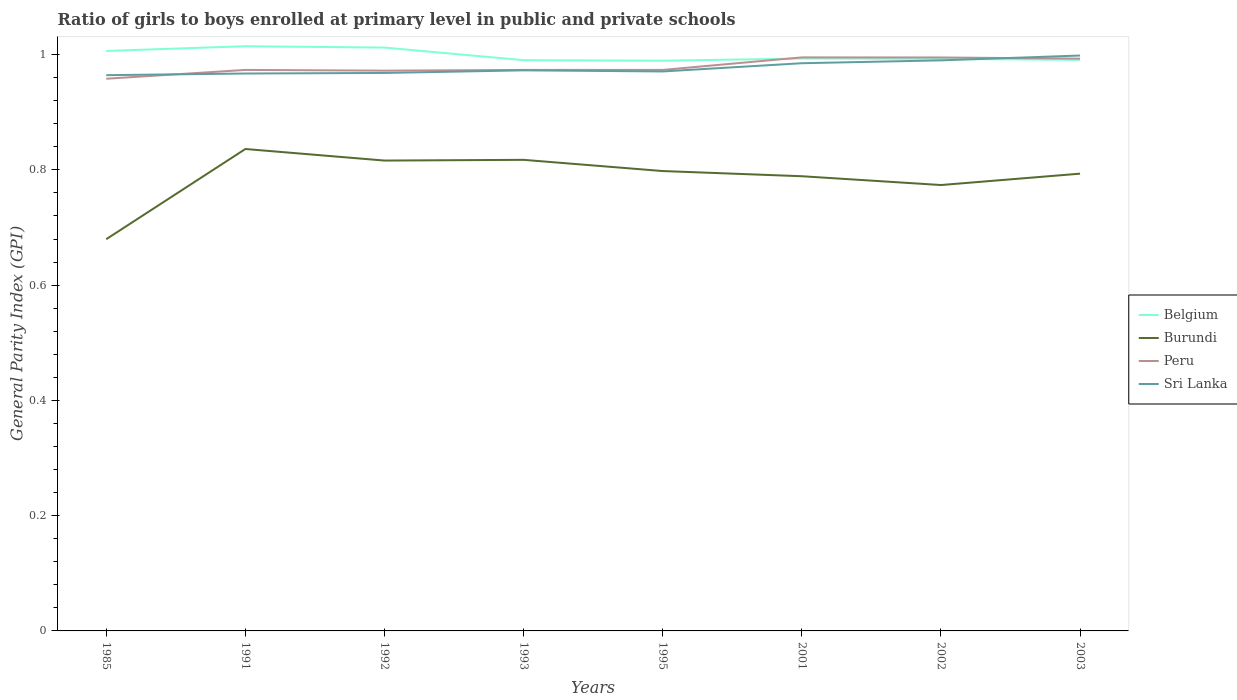Is the number of lines equal to the number of legend labels?
Ensure brevity in your answer.  Yes. Across all years, what is the maximum general parity index in Burundi?
Your answer should be compact. 0.68. What is the total general parity index in Burundi in the graph?
Provide a short and direct response. 0.02. What is the difference between the highest and the second highest general parity index in Peru?
Make the answer very short. 0.04. What is the difference between the highest and the lowest general parity index in Belgium?
Offer a terse response. 3. How many years are there in the graph?
Your answer should be compact. 8. What is the difference between two consecutive major ticks on the Y-axis?
Ensure brevity in your answer.  0.2. Are the values on the major ticks of Y-axis written in scientific E-notation?
Your answer should be compact. No. Does the graph contain any zero values?
Give a very brief answer. No. Does the graph contain grids?
Your response must be concise. No. Where does the legend appear in the graph?
Ensure brevity in your answer.  Center right. How are the legend labels stacked?
Your response must be concise. Vertical. What is the title of the graph?
Offer a terse response. Ratio of girls to boys enrolled at primary level in public and private schools. What is the label or title of the X-axis?
Offer a terse response. Years. What is the label or title of the Y-axis?
Provide a short and direct response. General Parity Index (GPI). What is the General Parity Index (GPI) of Belgium in 1985?
Provide a short and direct response. 1.01. What is the General Parity Index (GPI) in Burundi in 1985?
Your response must be concise. 0.68. What is the General Parity Index (GPI) of Peru in 1985?
Your answer should be compact. 0.96. What is the General Parity Index (GPI) of Sri Lanka in 1985?
Offer a terse response. 0.96. What is the General Parity Index (GPI) of Belgium in 1991?
Keep it short and to the point. 1.01. What is the General Parity Index (GPI) in Burundi in 1991?
Offer a very short reply. 0.84. What is the General Parity Index (GPI) in Peru in 1991?
Ensure brevity in your answer.  0.97. What is the General Parity Index (GPI) of Sri Lanka in 1991?
Provide a succinct answer. 0.97. What is the General Parity Index (GPI) of Belgium in 1992?
Make the answer very short. 1.01. What is the General Parity Index (GPI) of Burundi in 1992?
Your response must be concise. 0.82. What is the General Parity Index (GPI) in Peru in 1992?
Offer a terse response. 0.97. What is the General Parity Index (GPI) in Sri Lanka in 1992?
Offer a terse response. 0.97. What is the General Parity Index (GPI) in Belgium in 1993?
Keep it short and to the point. 0.99. What is the General Parity Index (GPI) in Burundi in 1993?
Provide a succinct answer. 0.82. What is the General Parity Index (GPI) of Peru in 1993?
Provide a short and direct response. 0.97. What is the General Parity Index (GPI) in Sri Lanka in 1993?
Make the answer very short. 0.97. What is the General Parity Index (GPI) of Belgium in 1995?
Offer a terse response. 0.99. What is the General Parity Index (GPI) in Burundi in 1995?
Ensure brevity in your answer.  0.8. What is the General Parity Index (GPI) of Peru in 1995?
Provide a succinct answer. 0.97. What is the General Parity Index (GPI) of Sri Lanka in 1995?
Provide a succinct answer. 0.97. What is the General Parity Index (GPI) in Belgium in 2001?
Offer a terse response. 0.99. What is the General Parity Index (GPI) in Burundi in 2001?
Ensure brevity in your answer.  0.79. What is the General Parity Index (GPI) of Peru in 2001?
Your answer should be compact. 1. What is the General Parity Index (GPI) of Sri Lanka in 2001?
Offer a terse response. 0.99. What is the General Parity Index (GPI) in Belgium in 2002?
Your answer should be very brief. 0.99. What is the General Parity Index (GPI) of Burundi in 2002?
Ensure brevity in your answer.  0.77. What is the General Parity Index (GPI) in Peru in 2002?
Make the answer very short. 1. What is the General Parity Index (GPI) in Sri Lanka in 2002?
Your answer should be very brief. 0.99. What is the General Parity Index (GPI) in Belgium in 2003?
Your answer should be very brief. 0.99. What is the General Parity Index (GPI) in Burundi in 2003?
Offer a very short reply. 0.79. What is the General Parity Index (GPI) of Peru in 2003?
Provide a short and direct response. 0.99. What is the General Parity Index (GPI) in Sri Lanka in 2003?
Ensure brevity in your answer.  1. Across all years, what is the maximum General Parity Index (GPI) in Belgium?
Provide a succinct answer. 1.01. Across all years, what is the maximum General Parity Index (GPI) in Burundi?
Provide a short and direct response. 0.84. Across all years, what is the maximum General Parity Index (GPI) of Peru?
Ensure brevity in your answer.  1. Across all years, what is the maximum General Parity Index (GPI) of Sri Lanka?
Make the answer very short. 1. Across all years, what is the minimum General Parity Index (GPI) in Belgium?
Offer a very short reply. 0.99. Across all years, what is the minimum General Parity Index (GPI) of Burundi?
Your answer should be compact. 0.68. Across all years, what is the minimum General Parity Index (GPI) in Peru?
Keep it short and to the point. 0.96. Across all years, what is the minimum General Parity Index (GPI) in Sri Lanka?
Keep it short and to the point. 0.96. What is the total General Parity Index (GPI) in Belgium in the graph?
Offer a very short reply. 7.99. What is the total General Parity Index (GPI) in Burundi in the graph?
Make the answer very short. 6.3. What is the total General Parity Index (GPI) of Peru in the graph?
Your answer should be compact. 7.83. What is the total General Parity Index (GPI) of Sri Lanka in the graph?
Provide a short and direct response. 7.82. What is the difference between the General Parity Index (GPI) in Belgium in 1985 and that in 1991?
Your answer should be very brief. -0.01. What is the difference between the General Parity Index (GPI) in Burundi in 1985 and that in 1991?
Provide a short and direct response. -0.16. What is the difference between the General Parity Index (GPI) of Peru in 1985 and that in 1991?
Ensure brevity in your answer.  -0.02. What is the difference between the General Parity Index (GPI) in Sri Lanka in 1985 and that in 1991?
Your answer should be compact. -0. What is the difference between the General Parity Index (GPI) of Belgium in 1985 and that in 1992?
Offer a terse response. -0.01. What is the difference between the General Parity Index (GPI) of Burundi in 1985 and that in 1992?
Your answer should be compact. -0.14. What is the difference between the General Parity Index (GPI) in Peru in 1985 and that in 1992?
Your response must be concise. -0.01. What is the difference between the General Parity Index (GPI) of Sri Lanka in 1985 and that in 1992?
Offer a terse response. -0. What is the difference between the General Parity Index (GPI) in Belgium in 1985 and that in 1993?
Keep it short and to the point. 0.02. What is the difference between the General Parity Index (GPI) in Burundi in 1985 and that in 1993?
Keep it short and to the point. -0.14. What is the difference between the General Parity Index (GPI) of Peru in 1985 and that in 1993?
Your answer should be very brief. -0.02. What is the difference between the General Parity Index (GPI) in Sri Lanka in 1985 and that in 1993?
Your answer should be very brief. -0.01. What is the difference between the General Parity Index (GPI) in Belgium in 1985 and that in 1995?
Keep it short and to the point. 0.02. What is the difference between the General Parity Index (GPI) of Burundi in 1985 and that in 1995?
Ensure brevity in your answer.  -0.12. What is the difference between the General Parity Index (GPI) in Peru in 1985 and that in 1995?
Keep it short and to the point. -0.02. What is the difference between the General Parity Index (GPI) of Sri Lanka in 1985 and that in 1995?
Provide a succinct answer. -0.01. What is the difference between the General Parity Index (GPI) in Belgium in 1985 and that in 2001?
Keep it short and to the point. 0.01. What is the difference between the General Parity Index (GPI) of Burundi in 1985 and that in 2001?
Provide a succinct answer. -0.11. What is the difference between the General Parity Index (GPI) of Peru in 1985 and that in 2001?
Make the answer very short. -0.04. What is the difference between the General Parity Index (GPI) in Sri Lanka in 1985 and that in 2001?
Give a very brief answer. -0.02. What is the difference between the General Parity Index (GPI) of Belgium in 1985 and that in 2002?
Offer a very short reply. 0.01. What is the difference between the General Parity Index (GPI) of Burundi in 1985 and that in 2002?
Offer a very short reply. -0.09. What is the difference between the General Parity Index (GPI) of Peru in 1985 and that in 2002?
Ensure brevity in your answer.  -0.04. What is the difference between the General Parity Index (GPI) of Sri Lanka in 1985 and that in 2002?
Provide a succinct answer. -0.03. What is the difference between the General Parity Index (GPI) in Belgium in 1985 and that in 2003?
Offer a terse response. 0.02. What is the difference between the General Parity Index (GPI) in Burundi in 1985 and that in 2003?
Your answer should be compact. -0.11. What is the difference between the General Parity Index (GPI) of Peru in 1985 and that in 2003?
Offer a very short reply. -0.03. What is the difference between the General Parity Index (GPI) in Sri Lanka in 1985 and that in 2003?
Provide a short and direct response. -0.03. What is the difference between the General Parity Index (GPI) in Belgium in 1991 and that in 1992?
Your answer should be compact. 0. What is the difference between the General Parity Index (GPI) in Burundi in 1991 and that in 1992?
Your response must be concise. 0.02. What is the difference between the General Parity Index (GPI) in Peru in 1991 and that in 1992?
Give a very brief answer. 0. What is the difference between the General Parity Index (GPI) of Sri Lanka in 1991 and that in 1992?
Provide a succinct answer. -0. What is the difference between the General Parity Index (GPI) of Belgium in 1991 and that in 1993?
Make the answer very short. 0.02. What is the difference between the General Parity Index (GPI) of Burundi in 1991 and that in 1993?
Keep it short and to the point. 0.02. What is the difference between the General Parity Index (GPI) of Sri Lanka in 1991 and that in 1993?
Give a very brief answer. -0.01. What is the difference between the General Parity Index (GPI) in Belgium in 1991 and that in 1995?
Your answer should be very brief. 0.03. What is the difference between the General Parity Index (GPI) of Burundi in 1991 and that in 1995?
Your answer should be compact. 0.04. What is the difference between the General Parity Index (GPI) in Sri Lanka in 1991 and that in 1995?
Provide a succinct answer. -0. What is the difference between the General Parity Index (GPI) in Belgium in 1991 and that in 2001?
Your response must be concise. 0.02. What is the difference between the General Parity Index (GPI) of Burundi in 1991 and that in 2001?
Ensure brevity in your answer.  0.05. What is the difference between the General Parity Index (GPI) in Peru in 1991 and that in 2001?
Provide a short and direct response. -0.02. What is the difference between the General Parity Index (GPI) of Sri Lanka in 1991 and that in 2001?
Your answer should be very brief. -0.02. What is the difference between the General Parity Index (GPI) in Belgium in 1991 and that in 2002?
Offer a very short reply. 0.02. What is the difference between the General Parity Index (GPI) of Burundi in 1991 and that in 2002?
Your answer should be very brief. 0.06. What is the difference between the General Parity Index (GPI) of Peru in 1991 and that in 2002?
Give a very brief answer. -0.02. What is the difference between the General Parity Index (GPI) of Sri Lanka in 1991 and that in 2002?
Provide a short and direct response. -0.02. What is the difference between the General Parity Index (GPI) in Belgium in 1991 and that in 2003?
Keep it short and to the point. 0.02. What is the difference between the General Parity Index (GPI) in Burundi in 1991 and that in 2003?
Offer a terse response. 0.04. What is the difference between the General Parity Index (GPI) of Peru in 1991 and that in 2003?
Keep it short and to the point. -0.02. What is the difference between the General Parity Index (GPI) of Sri Lanka in 1991 and that in 2003?
Your answer should be compact. -0.03. What is the difference between the General Parity Index (GPI) of Belgium in 1992 and that in 1993?
Make the answer very short. 0.02. What is the difference between the General Parity Index (GPI) of Burundi in 1992 and that in 1993?
Your response must be concise. -0. What is the difference between the General Parity Index (GPI) of Peru in 1992 and that in 1993?
Your response must be concise. -0. What is the difference between the General Parity Index (GPI) in Sri Lanka in 1992 and that in 1993?
Provide a succinct answer. -0. What is the difference between the General Parity Index (GPI) in Belgium in 1992 and that in 1995?
Make the answer very short. 0.02. What is the difference between the General Parity Index (GPI) of Burundi in 1992 and that in 1995?
Your answer should be very brief. 0.02. What is the difference between the General Parity Index (GPI) of Peru in 1992 and that in 1995?
Your response must be concise. -0. What is the difference between the General Parity Index (GPI) in Sri Lanka in 1992 and that in 1995?
Ensure brevity in your answer.  -0. What is the difference between the General Parity Index (GPI) of Belgium in 1992 and that in 2001?
Offer a terse response. 0.02. What is the difference between the General Parity Index (GPI) of Burundi in 1992 and that in 2001?
Offer a terse response. 0.03. What is the difference between the General Parity Index (GPI) of Peru in 1992 and that in 2001?
Make the answer very short. -0.02. What is the difference between the General Parity Index (GPI) in Sri Lanka in 1992 and that in 2001?
Offer a very short reply. -0.02. What is the difference between the General Parity Index (GPI) in Belgium in 1992 and that in 2002?
Your answer should be compact. 0.02. What is the difference between the General Parity Index (GPI) of Burundi in 1992 and that in 2002?
Give a very brief answer. 0.04. What is the difference between the General Parity Index (GPI) of Peru in 1992 and that in 2002?
Your answer should be very brief. -0.02. What is the difference between the General Parity Index (GPI) in Sri Lanka in 1992 and that in 2002?
Ensure brevity in your answer.  -0.02. What is the difference between the General Parity Index (GPI) of Belgium in 1992 and that in 2003?
Your answer should be compact. 0.02. What is the difference between the General Parity Index (GPI) in Burundi in 1992 and that in 2003?
Keep it short and to the point. 0.02. What is the difference between the General Parity Index (GPI) of Peru in 1992 and that in 2003?
Give a very brief answer. -0.02. What is the difference between the General Parity Index (GPI) of Sri Lanka in 1992 and that in 2003?
Keep it short and to the point. -0.03. What is the difference between the General Parity Index (GPI) of Belgium in 1993 and that in 1995?
Your answer should be compact. 0. What is the difference between the General Parity Index (GPI) in Burundi in 1993 and that in 1995?
Provide a succinct answer. 0.02. What is the difference between the General Parity Index (GPI) of Peru in 1993 and that in 1995?
Give a very brief answer. -0. What is the difference between the General Parity Index (GPI) in Sri Lanka in 1993 and that in 1995?
Offer a terse response. 0. What is the difference between the General Parity Index (GPI) of Belgium in 1993 and that in 2001?
Your answer should be very brief. -0. What is the difference between the General Parity Index (GPI) of Burundi in 1993 and that in 2001?
Provide a short and direct response. 0.03. What is the difference between the General Parity Index (GPI) in Peru in 1993 and that in 2001?
Your answer should be compact. -0.02. What is the difference between the General Parity Index (GPI) of Sri Lanka in 1993 and that in 2001?
Offer a very short reply. -0.01. What is the difference between the General Parity Index (GPI) of Belgium in 1993 and that in 2002?
Offer a very short reply. -0. What is the difference between the General Parity Index (GPI) in Burundi in 1993 and that in 2002?
Give a very brief answer. 0.04. What is the difference between the General Parity Index (GPI) of Peru in 1993 and that in 2002?
Provide a short and direct response. -0.02. What is the difference between the General Parity Index (GPI) of Sri Lanka in 1993 and that in 2002?
Offer a very short reply. -0.02. What is the difference between the General Parity Index (GPI) of Belgium in 1993 and that in 2003?
Your answer should be very brief. -0. What is the difference between the General Parity Index (GPI) of Burundi in 1993 and that in 2003?
Keep it short and to the point. 0.02. What is the difference between the General Parity Index (GPI) in Peru in 1993 and that in 2003?
Provide a short and direct response. -0.02. What is the difference between the General Parity Index (GPI) of Sri Lanka in 1993 and that in 2003?
Offer a terse response. -0.03. What is the difference between the General Parity Index (GPI) in Belgium in 1995 and that in 2001?
Provide a succinct answer. -0. What is the difference between the General Parity Index (GPI) in Burundi in 1995 and that in 2001?
Your response must be concise. 0.01. What is the difference between the General Parity Index (GPI) in Peru in 1995 and that in 2001?
Your response must be concise. -0.02. What is the difference between the General Parity Index (GPI) in Sri Lanka in 1995 and that in 2001?
Ensure brevity in your answer.  -0.01. What is the difference between the General Parity Index (GPI) in Belgium in 1995 and that in 2002?
Provide a succinct answer. -0. What is the difference between the General Parity Index (GPI) in Burundi in 1995 and that in 2002?
Give a very brief answer. 0.02. What is the difference between the General Parity Index (GPI) of Peru in 1995 and that in 2002?
Provide a succinct answer. -0.02. What is the difference between the General Parity Index (GPI) in Sri Lanka in 1995 and that in 2002?
Provide a short and direct response. -0.02. What is the difference between the General Parity Index (GPI) in Belgium in 1995 and that in 2003?
Your answer should be compact. -0. What is the difference between the General Parity Index (GPI) in Burundi in 1995 and that in 2003?
Offer a very short reply. 0. What is the difference between the General Parity Index (GPI) of Peru in 1995 and that in 2003?
Your answer should be compact. -0.02. What is the difference between the General Parity Index (GPI) in Sri Lanka in 1995 and that in 2003?
Provide a short and direct response. -0.03. What is the difference between the General Parity Index (GPI) of Belgium in 2001 and that in 2002?
Provide a short and direct response. 0. What is the difference between the General Parity Index (GPI) of Burundi in 2001 and that in 2002?
Offer a very short reply. 0.02. What is the difference between the General Parity Index (GPI) in Sri Lanka in 2001 and that in 2002?
Provide a short and direct response. -0.01. What is the difference between the General Parity Index (GPI) in Belgium in 2001 and that in 2003?
Your answer should be compact. 0. What is the difference between the General Parity Index (GPI) in Burundi in 2001 and that in 2003?
Provide a short and direct response. -0. What is the difference between the General Parity Index (GPI) of Peru in 2001 and that in 2003?
Offer a terse response. 0. What is the difference between the General Parity Index (GPI) in Sri Lanka in 2001 and that in 2003?
Make the answer very short. -0.01. What is the difference between the General Parity Index (GPI) in Belgium in 2002 and that in 2003?
Provide a short and direct response. 0. What is the difference between the General Parity Index (GPI) of Burundi in 2002 and that in 2003?
Offer a terse response. -0.02. What is the difference between the General Parity Index (GPI) of Peru in 2002 and that in 2003?
Your answer should be very brief. 0. What is the difference between the General Parity Index (GPI) of Sri Lanka in 2002 and that in 2003?
Provide a succinct answer. -0.01. What is the difference between the General Parity Index (GPI) in Belgium in 1985 and the General Parity Index (GPI) in Burundi in 1991?
Make the answer very short. 0.17. What is the difference between the General Parity Index (GPI) in Belgium in 1985 and the General Parity Index (GPI) in Peru in 1991?
Your answer should be compact. 0.03. What is the difference between the General Parity Index (GPI) in Belgium in 1985 and the General Parity Index (GPI) in Sri Lanka in 1991?
Your answer should be very brief. 0.04. What is the difference between the General Parity Index (GPI) in Burundi in 1985 and the General Parity Index (GPI) in Peru in 1991?
Make the answer very short. -0.29. What is the difference between the General Parity Index (GPI) in Burundi in 1985 and the General Parity Index (GPI) in Sri Lanka in 1991?
Ensure brevity in your answer.  -0.29. What is the difference between the General Parity Index (GPI) of Peru in 1985 and the General Parity Index (GPI) of Sri Lanka in 1991?
Your response must be concise. -0.01. What is the difference between the General Parity Index (GPI) of Belgium in 1985 and the General Parity Index (GPI) of Burundi in 1992?
Provide a short and direct response. 0.19. What is the difference between the General Parity Index (GPI) in Belgium in 1985 and the General Parity Index (GPI) in Peru in 1992?
Ensure brevity in your answer.  0.03. What is the difference between the General Parity Index (GPI) in Belgium in 1985 and the General Parity Index (GPI) in Sri Lanka in 1992?
Provide a succinct answer. 0.04. What is the difference between the General Parity Index (GPI) of Burundi in 1985 and the General Parity Index (GPI) of Peru in 1992?
Your response must be concise. -0.29. What is the difference between the General Parity Index (GPI) in Burundi in 1985 and the General Parity Index (GPI) in Sri Lanka in 1992?
Provide a succinct answer. -0.29. What is the difference between the General Parity Index (GPI) in Peru in 1985 and the General Parity Index (GPI) in Sri Lanka in 1992?
Give a very brief answer. -0.01. What is the difference between the General Parity Index (GPI) in Belgium in 1985 and the General Parity Index (GPI) in Burundi in 1993?
Offer a very short reply. 0.19. What is the difference between the General Parity Index (GPI) of Belgium in 1985 and the General Parity Index (GPI) of Peru in 1993?
Provide a succinct answer. 0.03. What is the difference between the General Parity Index (GPI) of Belgium in 1985 and the General Parity Index (GPI) of Sri Lanka in 1993?
Your answer should be very brief. 0.03. What is the difference between the General Parity Index (GPI) in Burundi in 1985 and the General Parity Index (GPI) in Peru in 1993?
Your answer should be compact. -0.29. What is the difference between the General Parity Index (GPI) in Burundi in 1985 and the General Parity Index (GPI) in Sri Lanka in 1993?
Ensure brevity in your answer.  -0.29. What is the difference between the General Parity Index (GPI) of Peru in 1985 and the General Parity Index (GPI) of Sri Lanka in 1993?
Offer a very short reply. -0.01. What is the difference between the General Parity Index (GPI) in Belgium in 1985 and the General Parity Index (GPI) in Burundi in 1995?
Provide a short and direct response. 0.21. What is the difference between the General Parity Index (GPI) of Belgium in 1985 and the General Parity Index (GPI) of Peru in 1995?
Your answer should be very brief. 0.03. What is the difference between the General Parity Index (GPI) in Belgium in 1985 and the General Parity Index (GPI) in Sri Lanka in 1995?
Give a very brief answer. 0.04. What is the difference between the General Parity Index (GPI) in Burundi in 1985 and the General Parity Index (GPI) in Peru in 1995?
Offer a very short reply. -0.29. What is the difference between the General Parity Index (GPI) in Burundi in 1985 and the General Parity Index (GPI) in Sri Lanka in 1995?
Give a very brief answer. -0.29. What is the difference between the General Parity Index (GPI) in Peru in 1985 and the General Parity Index (GPI) in Sri Lanka in 1995?
Make the answer very short. -0.01. What is the difference between the General Parity Index (GPI) in Belgium in 1985 and the General Parity Index (GPI) in Burundi in 2001?
Make the answer very short. 0.22. What is the difference between the General Parity Index (GPI) of Belgium in 1985 and the General Parity Index (GPI) of Peru in 2001?
Your answer should be compact. 0.01. What is the difference between the General Parity Index (GPI) in Belgium in 1985 and the General Parity Index (GPI) in Sri Lanka in 2001?
Offer a terse response. 0.02. What is the difference between the General Parity Index (GPI) in Burundi in 1985 and the General Parity Index (GPI) in Peru in 2001?
Offer a terse response. -0.32. What is the difference between the General Parity Index (GPI) of Burundi in 1985 and the General Parity Index (GPI) of Sri Lanka in 2001?
Your response must be concise. -0.31. What is the difference between the General Parity Index (GPI) in Peru in 1985 and the General Parity Index (GPI) in Sri Lanka in 2001?
Make the answer very short. -0.03. What is the difference between the General Parity Index (GPI) of Belgium in 1985 and the General Parity Index (GPI) of Burundi in 2002?
Your response must be concise. 0.23. What is the difference between the General Parity Index (GPI) of Belgium in 1985 and the General Parity Index (GPI) of Peru in 2002?
Your answer should be very brief. 0.01. What is the difference between the General Parity Index (GPI) in Belgium in 1985 and the General Parity Index (GPI) in Sri Lanka in 2002?
Make the answer very short. 0.02. What is the difference between the General Parity Index (GPI) in Burundi in 1985 and the General Parity Index (GPI) in Peru in 2002?
Make the answer very short. -0.32. What is the difference between the General Parity Index (GPI) of Burundi in 1985 and the General Parity Index (GPI) of Sri Lanka in 2002?
Make the answer very short. -0.31. What is the difference between the General Parity Index (GPI) in Peru in 1985 and the General Parity Index (GPI) in Sri Lanka in 2002?
Ensure brevity in your answer.  -0.03. What is the difference between the General Parity Index (GPI) in Belgium in 1985 and the General Parity Index (GPI) in Burundi in 2003?
Your answer should be compact. 0.21. What is the difference between the General Parity Index (GPI) in Belgium in 1985 and the General Parity Index (GPI) in Peru in 2003?
Your answer should be compact. 0.01. What is the difference between the General Parity Index (GPI) of Belgium in 1985 and the General Parity Index (GPI) of Sri Lanka in 2003?
Your response must be concise. 0.01. What is the difference between the General Parity Index (GPI) of Burundi in 1985 and the General Parity Index (GPI) of Peru in 2003?
Offer a very short reply. -0.31. What is the difference between the General Parity Index (GPI) in Burundi in 1985 and the General Parity Index (GPI) in Sri Lanka in 2003?
Offer a terse response. -0.32. What is the difference between the General Parity Index (GPI) of Peru in 1985 and the General Parity Index (GPI) of Sri Lanka in 2003?
Your answer should be very brief. -0.04. What is the difference between the General Parity Index (GPI) of Belgium in 1991 and the General Parity Index (GPI) of Burundi in 1992?
Your answer should be compact. 0.2. What is the difference between the General Parity Index (GPI) of Belgium in 1991 and the General Parity Index (GPI) of Peru in 1992?
Provide a short and direct response. 0.04. What is the difference between the General Parity Index (GPI) in Belgium in 1991 and the General Parity Index (GPI) in Sri Lanka in 1992?
Offer a terse response. 0.05. What is the difference between the General Parity Index (GPI) in Burundi in 1991 and the General Parity Index (GPI) in Peru in 1992?
Offer a terse response. -0.14. What is the difference between the General Parity Index (GPI) of Burundi in 1991 and the General Parity Index (GPI) of Sri Lanka in 1992?
Offer a terse response. -0.13. What is the difference between the General Parity Index (GPI) of Peru in 1991 and the General Parity Index (GPI) of Sri Lanka in 1992?
Make the answer very short. 0.01. What is the difference between the General Parity Index (GPI) in Belgium in 1991 and the General Parity Index (GPI) in Burundi in 1993?
Provide a succinct answer. 0.2. What is the difference between the General Parity Index (GPI) of Belgium in 1991 and the General Parity Index (GPI) of Peru in 1993?
Keep it short and to the point. 0.04. What is the difference between the General Parity Index (GPI) in Belgium in 1991 and the General Parity Index (GPI) in Sri Lanka in 1993?
Provide a succinct answer. 0.04. What is the difference between the General Parity Index (GPI) of Burundi in 1991 and the General Parity Index (GPI) of Peru in 1993?
Your response must be concise. -0.14. What is the difference between the General Parity Index (GPI) in Burundi in 1991 and the General Parity Index (GPI) in Sri Lanka in 1993?
Provide a short and direct response. -0.14. What is the difference between the General Parity Index (GPI) of Peru in 1991 and the General Parity Index (GPI) of Sri Lanka in 1993?
Offer a very short reply. 0. What is the difference between the General Parity Index (GPI) of Belgium in 1991 and the General Parity Index (GPI) of Burundi in 1995?
Ensure brevity in your answer.  0.22. What is the difference between the General Parity Index (GPI) in Belgium in 1991 and the General Parity Index (GPI) in Peru in 1995?
Make the answer very short. 0.04. What is the difference between the General Parity Index (GPI) of Belgium in 1991 and the General Parity Index (GPI) of Sri Lanka in 1995?
Provide a succinct answer. 0.04. What is the difference between the General Parity Index (GPI) of Burundi in 1991 and the General Parity Index (GPI) of Peru in 1995?
Your response must be concise. -0.14. What is the difference between the General Parity Index (GPI) of Burundi in 1991 and the General Parity Index (GPI) of Sri Lanka in 1995?
Keep it short and to the point. -0.13. What is the difference between the General Parity Index (GPI) of Peru in 1991 and the General Parity Index (GPI) of Sri Lanka in 1995?
Provide a succinct answer. 0. What is the difference between the General Parity Index (GPI) in Belgium in 1991 and the General Parity Index (GPI) in Burundi in 2001?
Give a very brief answer. 0.23. What is the difference between the General Parity Index (GPI) in Belgium in 1991 and the General Parity Index (GPI) in Peru in 2001?
Keep it short and to the point. 0.02. What is the difference between the General Parity Index (GPI) of Belgium in 1991 and the General Parity Index (GPI) of Sri Lanka in 2001?
Provide a short and direct response. 0.03. What is the difference between the General Parity Index (GPI) of Burundi in 1991 and the General Parity Index (GPI) of Peru in 2001?
Give a very brief answer. -0.16. What is the difference between the General Parity Index (GPI) in Burundi in 1991 and the General Parity Index (GPI) in Sri Lanka in 2001?
Ensure brevity in your answer.  -0.15. What is the difference between the General Parity Index (GPI) of Peru in 1991 and the General Parity Index (GPI) of Sri Lanka in 2001?
Your response must be concise. -0.01. What is the difference between the General Parity Index (GPI) of Belgium in 1991 and the General Parity Index (GPI) of Burundi in 2002?
Your answer should be compact. 0.24. What is the difference between the General Parity Index (GPI) of Belgium in 1991 and the General Parity Index (GPI) of Peru in 2002?
Give a very brief answer. 0.02. What is the difference between the General Parity Index (GPI) of Belgium in 1991 and the General Parity Index (GPI) of Sri Lanka in 2002?
Give a very brief answer. 0.02. What is the difference between the General Parity Index (GPI) of Burundi in 1991 and the General Parity Index (GPI) of Peru in 2002?
Your answer should be compact. -0.16. What is the difference between the General Parity Index (GPI) in Burundi in 1991 and the General Parity Index (GPI) in Sri Lanka in 2002?
Ensure brevity in your answer.  -0.15. What is the difference between the General Parity Index (GPI) in Peru in 1991 and the General Parity Index (GPI) in Sri Lanka in 2002?
Offer a very short reply. -0.02. What is the difference between the General Parity Index (GPI) in Belgium in 1991 and the General Parity Index (GPI) in Burundi in 2003?
Make the answer very short. 0.22. What is the difference between the General Parity Index (GPI) of Belgium in 1991 and the General Parity Index (GPI) of Peru in 2003?
Ensure brevity in your answer.  0.02. What is the difference between the General Parity Index (GPI) in Belgium in 1991 and the General Parity Index (GPI) in Sri Lanka in 2003?
Provide a succinct answer. 0.02. What is the difference between the General Parity Index (GPI) of Burundi in 1991 and the General Parity Index (GPI) of Peru in 2003?
Give a very brief answer. -0.16. What is the difference between the General Parity Index (GPI) of Burundi in 1991 and the General Parity Index (GPI) of Sri Lanka in 2003?
Offer a very short reply. -0.16. What is the difference between the General Parity Index (GPI) in Peru in 1991 and the General Parity Index (GPI) in Sri Lanka in 2003?
Ensure brevity in your answer.  -0.03. What is the difference between the General Parity Index (GPI) in Belgium in 1992 and the General Parity Index (GPI) in Burundi in 1993?
Give a very brief answer. 0.19. What is the difference between the General Parity Index (GPI) in Belgium in 1992 and the General Parity Index (GPI) in Peru in 1993?
Provide a short and direct response. 0.04. What is the difference between the General Parity Index (GPI) of Belgium in 1992 and the General Parity Index (GPI) of Sri Lanka in 1993?
Provide a short and direct response. 0.04. What is the difference between the General Parity Index (GPI) of Burundi in 1992 and the General Parity Index (GPI) of Peru in 1993?
Provide a short and direct response. -0.16. What is the difference between the General Parity Index (GPI) of Burundi in 1992 and the General Parity Index (GPI) of Sri Lanka in 1993?
Provide a short and direct response. -0.16. What is the difference between the General Parity Index (GPI) of Peru in 1992 and the General Parity Index (GPI) of Sri Lanka in 1993?
Provide a short and direct response. -0. What is the difference between the General Parity Index (GPI) of Belgium in 1992 and the General Parity Index (GPI) of Burundi in 1995?
Your response must be concise. 0.21. What is the difference between the General Parity Index (GPI) in Belgium in 1992 and the General Parity Index (GPI) in Peru in 1995?
Give a very brief answer. 0.04. What is the difference between the General Parity Index (GPI) in Belgium in 1992 and the General Parity Index (GPI) in Sri Lanka in 1995?
Provide a succinct answer. 0.04. What is the difference between the General Parity Index (GPI) of Burundi in 1992 and the General Parity Index (GPI) of Peru in 1995?
Make the answer very short. -0.16. What is the difference between the General Parity Index (GPI) in Burundi in 1992 and the General Parity Index (GPI) in Sri Lanka in 1995?
Your response must be concise. -0.15. What is the difference between the General Parity Index (GPI) in Peru in 1992 and the General Parity Index (GPI) in Sri Lanka in 1995?
Give a very brief answer. 0. What is the difference between the General Parity Index (GPI) of Belgium in 1992 and the General Parity Index (GPI) of Burundi in 2001?
Your response must be concise. 0.22. What is the difference between the General Parity Index (GPI) of Belgium in 1992 and the General Parity Index (GPI) of Peru in 2001?
Your response must be concise. 0.02. What is the difference between the General Parity Index (GPI) in Belgium in 1992 and the General Parity Index (GPI) in Sri Lanka in 2001?
Offer a very short reply. 0.03. What is the difference between the General Parity Index (GPI) of Burundi in 1992 and the General Parity Index (GPI) of Peru in 2001?
Ensure brevity in your answer.  -0.18. What is the difference between the General Parity Index (GPI) in Burundi in 1992 and the General Parity Index (GPI) in Sri Lanka in 2001?
Make the answer very short. -0.17. What is the difference between the General Parity Index (GPI) of Peru in 1992 and the General Parity Index (GPI) of Sri Lanka in 2001?
Keep it short and to the point. -0.01. What is the difference between the General Parity Index (GPI) of Belgium in 1992 and the General Parity Index (GPI) of Burundi in 2002?
Make the answer very short. 0.24. What is the difference between the General Parity Index (GPI) of Belgium in 1992 and the General Parity Index (GPI) of Peru in 2002?
Give a very brief answer. 0.02. What is the difference between the General Parity Index (GPI) in Belgium in 1992 and the General Parity Index (GPI) in Sri Lanka in 2002?
Make the answer very short. 0.02. What is the difference between the General Parity Index (GPI) in Burundi in 1992 and the General Parity Index (GPI) in Peru in 2002?
Offer a terse response. -0.18. What is the difference between the General Parity Index (GPI) of Burundi in 1992 and the General Parity Index (GPI) of Sri Lanka in 2002?
Provide a succinct answer. -0.17. What is the difference between the General Parity Index (GPI) in Peru in 1992 and the General Parity Index (GPI) in Sri Lanka in 2002?
Your answer should be compact. -0.02. What is the difference between the General Parity Index (GPI) in Belgium in 1992 and the General Parity Index (GPI) in Burundi in 2003?
Your answer should be very brief. 0.22. What is the difference between the General Parity Index (GPI) of Belgium in 1992 and the General Parity Index (GPI) of Peru in 2003?
Provide a succinct answer. 0.02. What is the difference between the General Parity Index (GPI) of Belgium in 1992 and the General Parity Index (GPI) of Sri Lanka in 2003?
Provide a short and direct response. 0.01. What is the difference between the General Parity Index (GPI) in Burundi in 1992 and the General Parity Index (GPI) in Peru in 2003?
Your response must be concise. -0.18. What is the difference between the General Parity Index (GPI) of Burundi in 1992 and the General Parity Index (GPI) of Sri Lanka in 2003?
Provide a short and direct response. -0.18. What is the difference between the General Parity Index (GPI) in Peru in 1992 and the General Parity Index (GPI) in Sri Lanka in 2003?
Offer a very short reply. -0.03. What is the difference between the General Parity Index (GPI) of Belgium in 1993 and the General Parity Index (GPI) of Burundi in 1995?
Provide a succinct answer. 0.19. What is the difference between the General Parity Index (GPI) of Belgium in 1993 and the General Parity Index (GPI) of Peru in 1995?
Provide a short and direct response. 0.02. What is the difference between the General Parity Index (GPI) of Belgium in 1993 and the General Parity Index (GPI) of Sri Lanka in 1995?
Your response must be concise. 0.02. What is the difference between the General Parity Index (GPI) in Burundi in 1993 and the General Parity Index (GPI) in Peru in 1995?
Your answer should be compact. -0.16. What is the difference between the General Parity Index (GPI) in Burundi in 1993 and the General Parity Index (GPI) in Sri Lanka in 1995?
Offer a very short reply. -0.15. What is the difference between the General Parity Index (GPI) of Peru in 1993 and the General Parity Index (GPI) of Sri Lanka in 1995?
Offer a very short reply. 0. What is the difference between the General Parity Index (GPI) in Belgium in 1993 and the General Parity Index (GPI) in Burundi in 2001?
Provide a short and direct response. 0.2. What is the difference between the General Parity Index (GPI) of Belgium in 1993 and the General Parity Index (GPI) of Peru in 2001?
Offer a terse response. -0. What is the difference between the General Parity Index (GPI) in Belgium in 1993 and the General Parity Index (GPI) in Sri Lanka in 2001?
Your response must be concise. 0.01. What is the difference between the General Parity Index (GPI) of Burundi in 1993 and the General Parity Index (GPI) of Peru in 2001?
Your answer should be very brief. -0.18. What is the difference between the General Parity Index (GPI) of Burundi in 1993 and the General Parity Index (GPI) of Sri Lanka in 2001?
Make the answer very short. -0.17. What is the difference between the General Parity Index (GPI) of Peru in 1993 and the General Parity Index (GPI) of Sri Lanka in 2001?
Offer a terse response. -0.01. What is the difference between the General Parity Index (GPI) of Belgium in 1993 and the General Parity Index (GPI) of Burundi in 2002?
Your answer should be compact. 0.22. What is the difference between the General Parity Index (GPI) of Belgium in 1993 and the General Parity Index (GPI) of Peru in 2002?
Ensure brevity in your answer.  -0. What is the difference between the General Parity Index (GPI) of Burundi in 1993 and the General Parity Index (GPI) of Peru in 2002?
Provide a short and direct response. -0.18. What is the difference between the General Parity Index (GPI) of Burundi in 1993 and the General Parity Index (GPI) of Sri Lanka in 2002?
Keep it short and to the point. -0.17. What is the difference between the General Parity Index (GPI) of Peru in 1993 and the General Parity Index (GPI) of Sri Lanka in 2002?
Keep it short and to the point. -0.02. What is the difference between the General Parity Index (GPI) in Belgium in 1993 and the General Parity Index (GPI) in Burundi in 2003?
Provide a short and direct response. 0.2. What is the difference between the General Parity Index (GPI) in Belgium in 1993 and the General Parity Index (GPI) in Peru in 2003?
Offer a terse response. -0. What is the difference between the General Parity Index (GPI) in Belgium in 1993 and the General Parity Index (GPI) in Sri Lanka in 2003?
Keep it short and to the point. -0.01. What is the difference between the General Parity Index (GPI) in Burundi in 1993 and the General Parity Index (GPI) in Peru in 2003?
Provide a short and direct response. -0.18. What is the difference between the General Parity Index (GPI) of Burundi in 1993 and the General Parity Index (GPI) of Sri Lanka in 2003?
Give a very brief answer. -0.18. What is the difference between the General Parity Index (GPI) of Peru in 1993 and the General Parity Index (GPI) of Sri Lanka in 2003?
Provide a succinct answer. -0.03. What is the difference between the General Parity Index (GPI) in Belgium in 1995 and the General Parity Index (GPI) in Burundi in 2001?
Your answer should be very brief. 0.2. What is the difference between the General Parity Index (GPI) in Belgium in 1995 and the General Parity Index (GPI) in Peru in 2001?
Your response must be concise. -0.01. What is the difference between the General Parity Index (GPI) of Belgium in 1995 and the General Parity Index (GPI) of Sri Lanka in 2001?
Give a very brief answer. 0. What is the difference between the General Parity Index (GPI) in Burundi in 1995 and the General Parity Index (GPI) in Peru in 2001?
Your answer should be very brief. -0.2. What is the difference between the General Parity Index (GPI) in Burundi in 1995 and the General Parity Index (GPI) in Sri Lanka in 2001?
Offer a very short reply. -0.19. What is the difference between the General Parity Index (GPI) in Peru in 1995 and the General Parity Index (GPI) in Sri Lanka in 2001?
Give a very brief answer. -0.01. What is the difference between the General Parity Index (GPI) in Belgium in 1995 and the General Parity Index (GPI) in Burundi in 2002?
Provide a short and direct response. 0.22. What is the difference between the General Parity Index (GPI) of Belgium in 1995 and the General Parity Index (GPI) of Peru in 2002?
Keep it short and to the point. -0.01. What is the difference between the General Parity Index (GPI) of Belgium in 1995 and the General Parity Index (GPI) of Sri Lanka in 2002?
Your answer should be very brief. -0. What is the difference between the General Parity Index (GPI) in Burundi in 1995 and the General Parity Index (GPI) in Peru in 2002?
Offer a terse response. -0.2. What is the difference between the General Parity Index (GPI) of Burundi in 1995 and the General Parity Index (GPI) of Sri Lanka in 2002?
Make the answer very short. -0.19. What is the difference between the General Parity Index (GPI) of Peru in 1995 and the General Parity Index (GPI) of Sri Lanka in 2002?
Make the answer very short. -0.02. What is the difference between the General Parity Index (GPI) of Belgium in 1995 and the General Parity Index (GPI) of Burundi in 2003?
Offer a terse response. 0.2. What is the difference between the General Parity Index (GPI) in Belgium in 1995 and the General Parity Index (GPI) in Peru in 2003?
Provide a short and direct response. -0. What is the difference between the General Parity Index (GPI) in Belgium in 1995 and the General Parity Index (GPI) in Sri Lanka in 2003?
Offer a very short reply. -0.01. What is the difference between the General Parity Index (GPI) of Burundi in 1995 and the General Parity Index (GPI) of Peru in 2003?
Provide a short and direct response. -0.2. What is the difference between the General Parity Index (GPI) of Burundi in 1995 and the General Parity Index (GPI) of Sri Lanka in 2003?
Offer a very short reply. -0.2. What is the difference between the General Parity Index (GPI) of Peru in 1995 and the General Parity Index (GPI) of Sri Lanka in 2003?
Your answer should be very brief. -0.03. What is the difference between the General Parity Index (GPI) of Belgium in 2001 and the General Parity Index (GPI) of Burundi in 2002?
Keep it short and to the point. 0.22. What is the difference between the General Parity Index (GPI) in Belgium in 2001 and the General Parity Index (GPI) in Peru in 2002?
Give a very brief answer. -0. What is the difference between the General Parity Index (GPI) of Belgium in 2001 and the General Parity Index (GPI) of Sri Lanka in 2002?
Ensure brevity in your answer.  0. What is the difference between the General Parity Index (GPI) of Burundi in 2001 and the General Parity Index (GPI) of Peru in 2002?
Your response must be concise. -0.21. What is the difference between the General Parity Index (GPI) of Burundi in 2001 and the General Parity Index (GPI) of Sri Lanka in 2002?
Keep it short and to the point. -0.2. What is the difference between the General Parity Index (GPI) of Peru in 2001 and the General Parity Index (GPI) of Sri Lanka in 2002?
Give a very brief answer. 0.01. What is the difference between the General Parity Index (GPI) of Belgium in 2001 and the General Parity Index (GPI) of Burundi in 2003?
Provide a succinct answer. 0.2. What is the difference between the General Parity Index (GPI) of Belgium in 2001 and the General Parity Index (GPI) of Peru in 2003?
Your answer should be compact. 0. What is the difference between the General Parity Index (GPI) of Belgium in 2001 and the General Parity Index (GPI) of Sri Lanka in 2003?
Offer a terse response. -0.01. What is the difference between the General Parity Index (GPI) of Burundi in 2001 and the General Parity Index (GPI) of Peru in 2003?
Make the answer very short. -0.2. What is the difference between the General Parity Index (GPI) in Burundi in 2001 and the General Parity Index (GPI) in Sri Lanka in 2003?
Give a very brief answer. -0.21. What is the difference between the General Parity Index (GPI) in Peru in 2001 and the General Parity Index (GPI) in Sri Lanka in 2003?
Provide a short and direct response. -0. What is the difference between the General Parity Index (GPI) of Belgium in 2002 and the General Parity Index (GPI) of Burundi in 2003?
Provide a succinct answer. 0.2. What is the difference between the General Parity Index (GPI) of Belgium in 2002 and the General Parity Index (GPI) of Peru in 2003?
Your answer should be very brief. -0. What is the difference between the General Parity Index (GPI) in Belgium in 2002 and the General Parity Index (GPI) in Sri Lanka in 2003?
Provide a succinct answer. -0.01. What is the difference between the General Parity Index (GPI) in Burundi in 2002 and the General Parity Index (GPI) in Peru in 2003?
Your answer should be compact. -0.22. What is the difference between the General Parity Index (GPI) of Burundi in 2002 and the General Parity Index (GPI) of Sri Lanka in 2003?
Keep it short and to the point. -0.22. What is the difference between the General Parity Index (GPI) of Peru in 2002 and the General Parity Index (GPI) of Sri Lanka in 2003?
Offer a terse response. -0. What is the average General Parity Index (GPI) of Burundi per year?
Offer a terse response. 0.79. What is the average General Parity Index (GPI) of Peru per year?
Keep it short and to the point. 0.98. What is the average General Parity Index (GPI) of Sri Lanka per year?
Make the answer very short. 0.98. In the year 1985, what is the difference between the General Parity Index (GPI) of Belgium and General Parity Index (GPI) of Burundi?
Provide a short and direct response. 0.33. In the year 1985, what is the difference between the General Parity Index (GPI) of Belgium and General Parity Index (GPI) of Peru?
Your answer should be very brief. 0.05. In the year 1985, what is the difference between the General Parity Index (GPI) in Belgium and General Parity Index (GPI) in Sri Lanka?
Provide a short and direct response. 0.04. In the year 1985, what is the difference between the General Parity Index (GPI) of Burundi and General Parity Index (GPI) of Peru?
Make the answer very short. -0.28. In the year 1985, what is the difference between the General Parity Index (GPI) of Burundi and General Parity Index (GPI) of Sri Lanka?
Ensure brevity in your answer.  -0.28. In the year 1985, what is the difference between the General Parity Index (GPI) of Peru and General Parity Index (GPI) of Sri Lanka?
Offer a very short reply. -0.01. In the year 1991, what is the difference between the General Parity Index (GPI) in Belgium and General Parity Index (GPI) in Burundi?
Keep it short and to the point. 0.18. In the year 1991, what is the difference between the General Parity Index (GPI) in Belgium and General Parity Index (GPI) in Peru?
Keep it short and to the point. 0.04. In the year 1991, what is the difference between the General Parity Index (GPI) of Belgium and General Parity Index (GPI) of Sri Lanka?
Provide a short and direct response. 0.05. In the year 1991, what is the difference between the General Parity Index (GPI) in Burundi and General Parity Index (GPI) in Peru?
Offer a very short reply. -0.14. In the year 1991, what is the difference between the General Parity Index (GPI) in Burundi and General Parity Index (GPI) in Sri Lanka?
Your response must be concise. -0.13. In the year 1991, what is the difference between the General Parity Index (GPI) of Peru and General Parity Index (GPI) of Sri Lanka?
Offer a very short reply. 0.01. In the year 1992, what is the difference between the General Parity Index (GPI) in Belgium and General Parity Index (GPI) in Burundi?
Provide a short and direct response. 0.2. In the year 1992, what is the difference between the General Parity Index (GPI) in Belgium and General Parity Index (GPI) in Peru?
Provide a succinct answer. 0.04. In the year 1992, what is the difference between the General Parity Index (GPI) in Belgium and General Parity Index (GPI) in Sri Lanka?
Give a very brief answer. 0.04. In the year 1992, what is the difference between the General Parity Index (GPI) in Burundi and General Parity Index (GPI) in Peru?
Your answer should be compact. -0.16. In the year 1992, what is the difference between the General Parity Index (GPI) of Burundi and General Parity Index (GPI) of Sri Lanka?
Make the answer very short. -0.15. In the year 1992, what is the difference between the General Parity Index (GPI) of Peru and General Parity Index (GPI) of Sri Lanka?
Make the answer very short. 0. In the year 1993, what is the difference between the General Parity Index (GPI) in Belgium and General Parity Index (GPI) in Burundi?
Your answer should be compact. 0.17. In the year 1993, what is the difference between the General Parity Index (GPI) of Belgium and General Parity Index (GPI) of Peru?
Ensure brevity in your answer.  0.02. In the year 1993, what is the difference between the General Parity Index (GPI) in Belgium and General Parity Index (GPI) in Sri Lanka?
Offer a very short reply. 0.02. In the year 1993, what is the difference between the General Parity Index (GPI) of Burundi and General Parity Index (GPI) of Peru?
Provide a short and direct response. -0.16. In the year 1993, what is the difference between the General Parity Index (GPI) of Burundi and General Parity Index (GPI) of Sri Lanka?
Give a very brief answer. -0.16. In the year 1993, what is the difference between the General Parity Index (GPI) in Peru and General Parity Index (GPI) in Sri Lanka?
Give a very brief answer. 0. In the year 1995, what is the difference between the General Parity Index (GPI) in Belgium and General Parity Index (GPI) in Burundi?
Make the answer very short. 0.19. In the year 1995, what is the difference between the General Parity Index (GPI) in Belgium and General Parity Index (GPI) in Peru?
Your answer should be compact. 0.02. In the year 1995, what is the difference between the General Parity Index (GPI) of Belgium and General Parity Index (GPI) of Sri Lanka?
Keep it short and to the point. 0.02. In the year 1995, what is the difference between the General Parity Index (GPI) in Burundi and General Parity Index (GPI) in Peru?
Offer a very short reply. -0.18. In the year 1995, what is the difference between the General Parity Index (GPI) in Burundi and General Parity Index (GPI) in Sri Lanka?
Provide a succinct answer. -0.17. In the year 1995, what is the difference between the General Parity Index (GPI) in Peru and General Parity Index (GPI) in Sri Lanka?
Provide a short and direct response. 0. In the year 2001, what is the difference between the General Parity Index (GPI) in Belgium and General Parity Index (GPI) in Burundi?
Your answer should be very brief. 0.2. In the year 2001, what is the difference between the General Parity Index (GPI) in Belgium and General Parity Index (GPI) in Peru?
Your response must be concise. -0. In the year 2001, what is the difference between the General Parity Index (GPI) in Belgium and General Parity Index (GPI) in Sri Lanka?
Make the answer very short. 0.01. In the year 2001, what is the difference between the General Parity Index (GPI) in Burundi and General Parity Index (GPI) in Peru?
Keep it short and to the point. -0.21. In the year 2001, what is the difference between the General Parity Index (GPI) in Burundi and General Parity Index (GPI) in Sri Lanka?
Give a very brief answer. -0.2. In the year 2001, what is the difference between the General Parity Index (GPI) of Peru and General Parity Index (GPI) of Sri Lanka?
Your answer should be compact. 0.01. In the year 2002, what is the difference between the General Parity Index (GPI) of Belgium and General Parity Index (GPI) of Burundi?
Offer a very short reply. 0.22. In the year 2002, what is the difference between the General Parity Index (GPI) of Belgium and General Parity Index (GPI) of Peru?
Provide a succinct answer. -0. In the year 2002, what is the difference between the General Parity Index (GPI) in Belgium and General Parity Index (GPI) in Sri Lanka?
Offer a very short reply. 0. In the year 2002, what is the difference between the General Parity Index (GPI) of Burundi and General Parity Index (GPI) of Peru?
Provide a succinct answer. -0.22. In the year 2002, what is the difference between the General Parity Index (GPI) in Burundi and General Parity Index (GPI) in Sri Lanka?
Your response must be concise. -0.22. In the year 2002, what is the difference between the General Parity Index (GPI) of Peru and General Parity Index (GPI) of Sri Lanka?
Make the answer very short. 0.01. In the year 2003, what is the difference between the General Parity Index (GPI) in Belgium and General Parity Index (GPI) in Burundi?
Offer a very short reply. 0.2. In the year 2003, what is the difference between the General Parity Index (GPI) in Belgium and General Parity Index (GPI) in Peru?
Your answer should be very brief. -0. In the year 2003, what is the difference between the General Parity Index (GPI) in Belgium and General Parity Index (GPI) in Sri Lanka?
Offer a terse response. -0.01. In the year 2003, what is the difference between the General Parity Index (GPI) in Burundi and General Parity Index (GPI) in Peru?
Your answer should be compact. -0.2. In the year 2003, what is the difference between the General Parity Index (GPI) of Burundi and General Parity Index (GPI) of Sri Lanka?
Your answer should be very brief. -0.2. In the year 2003, what is the difference between the General Parity Index (GPI) in Peru and General Parity Index (GPI) in Sri Lanka?
Provide a succinct answer. -0.01. What is the ratio of the General Parity Index (GPI) in Belgium in 1985 to that in 1991?
Provide a short and direct response. 0.99. What is the ratio of the General Parity Index (GPI) in Burundi in 1985 to that in 1991?
Make the answer very short. 0.81. What is the ratio of the General Parity Index (GPI) of Peru in 1985 to that in 1991?
Your answer should be compact. 0.98. What is the ratio of the General Parity Index (GPI) of Sri Lanka in 1985 to that in 1991?
Give a very brief answer. 1. What is the ratio of the General Parity Index (GPI) in Burundi in 1985 to that in 1992?
Your response must be concise. 0.83. What is the ratio of the General Parity Index (GPI) of Peru in 1985 to that in 1992?
Offer a terse response. 0.99. What is the ratio of the General Parity Index (GPI) of Belgium in 1985 to that in 1993?
Keep it short and to the point. 1.02. What is the ratio of the General Parity Index (GPI) in Burundi in 1985 to that in 1993?
Make the answer very short. 0.83. What is the ratio of the General Parity Index (GPI) in Peru in 1985 to that in 1993?
Keep it short and to the point. 0.98. What is the ratio of the General Parity Index (GPI) of Sri Lanka in 1985 to that in 1993?
Provide a short and direct response. 0.99. What is the ratio of the General Parity Index (GPI) of Belgium in 1985 to that in 1995?
Your response must be concise. 1.02. What is the ratio of the General Parity Index (GPI) in Burundi in 1985 to that in 1995?
Provide a short and direct response. 0.85. What is the ratio of the General Parity Index (GPI) in Peru in 1985 to that in 1995?
Your response must be concise. 0.98. What is the ratio of the General Parity Index (GPI) of Sri Lanka in 1985 to that in 1995?
Provide a succinct answer. 0.99. What is the ratio of the General Parity Index (GPI) of Belgium in 1985 to that in 2001?
Provide a succinct answer. 1.01. What is the ratio of the General Parity Index (GPI) in Burundi in 1985 to that in 2001?
Offer a terse response. 0.86. What is the ratio of the General Parity Index (GPI) in Peru in 1985 to that in 2001?
Ensure brevity in your answer.  0.96. What is the ratio of the General Parity Index (GPI) of Belgium in 1985 to that in 2002?
Provide a succinct answer. 1.01. What is the ratio of the General Parity Index (GPI) in Burundi in 1985 to that in 2002?
Keep it short and to the point. 0.88. What is the ratio of the General Parity Index (GPI) of Peru in 1985 to that in 2002?
Keep it short and to the point. 0.96. What is the ratio of the General Parity Index (GPI) of Sri Lanka in 1985 to that in 2002?
Give a very brief answer. 0.97. What is the ratio of the General Parity Index (GPI) in Belgium in 1985 to that in 2003?
Make the answer very short. 1.02. What is the ratio of the General Parity Index (GPI) of Burundi in 1985 to that in 2003?
Your answer should be compact. 0.86. What is the ratio of the General Parity Index (GPI) in Peru in 1985 to that in 2003?
Your response must be concise. 0.96. What is the ratio of the General Parity Index (GPI) in Sri Lanka in 1985 to that in 2003?
Your response must be concise. 0.97. What is the ratio of the General Parity Index (GPI) of Belgium in 1991 to that in 1992?
Your answer should be very brief. 1. What is the ratio of the General Parity Index (GPI) in Burundi in 1991 to that in 1992?
Offer a terse response. 1.02. What is the ratio of the General Parity Index (GPI) of Sri Lanka in 1991 to that in 1992?
Provide a short and direct response. 1. What is the ratio of the General Parity Index (GPI) of Belgium in 1991 to that in 1993?
Make the answer very short. 1.02. What is the ratio of the General Parity Index (GPI) in Burundi in 1991 to that in 1993?
Make the answer very short. 1.02. What is the ratio of the General Parity Index (GPI) in Sri Lanka in 1991 to that in 1993?
Make the answer very short. 0.99. What is the ratio of the General Parity Index (GPI) in Belgium in 1991 to that in 1995?
Give a very brief answer. 1.03. What is the ratio of the General Parity Index (GPI) in Burundi in 1991 to that in 1995?
Keep it short and to the point. 1.05. What is the ratio of the General Parity Index (GPI) in Belgium in 1991 to that in 2001?
Keep it short and to the point. 1.02. What is the ratio of the General Parity Index (GPI) of Burundi in 1991 to that in 2001?
Provide a succinct answer. 1.06. What is the ratio of the General Parity Index (GPI) of Peru in 1991 to that in 2001?
Keep it short and to the point. 0.98. What is the ratio of the General Parity Index (GPI) in Sri Lanka in 1991 to that in 2001?
Offer a terse response. 0.98. What is the ratio of the General Parity Index (GPI) of Belgium in 1991 to that in 2002?
Give a very brief answer. 1.02. What is the ratio of the General Parity Index (GPI) of Burundi in 1991 to that in 2002?
Provide a short and direct response. 1.08. What is the ratio of the General Parity Index (GPI) in Peru in 1991 to that in 2002?
Keep it short and to the point. 0.98. What is the ratio of the General Parity Index (GPI) in Sri Lanka in 1991 to that in 2002?
Offer a terse response. 0.98. What is the ratio of the General Parity Index (GPI) of Belgium in 1991 to that in 2003?
Make the answer very short. 1.02. What is the ratio of the General Parity Index (GPI) of Burundi in 1991 to that in 2003?
Provide a short and direct response. 1.05. What is the ratio of the General Parity Index (GPI) of Peru in 1991 to that in 2003?
Offer a terse response. 0.98. What is the ratio of the General Parity Index (GPI) of Sri Lanka in 1991 to that in 2003?
Your answer should be compact. 0.97. What is the ratio of the General Parity Index (GPI) of Belgium in 1992 to that in 1993?
Offer a very short reply. 1.02. What is the ratio of the General Parity Index (GPI) of Burundi in 1992 to that in 1993?
Give a very brief answer. 1. What is the ratio of the General Parity Index (GPI) of Sri Lanka in 1992 to that in 1993?
Provide a succinct answer. 1. What is the ratio of the General Parity Index (GPI) of Burundi in 1992 to that in 1995?
Give a very brief answer. 1.02. What is the ratio of the General Parity Index (GPI) in Belgium in 1992 to that in 2001?
Provide a succinct answer. 1.02. What is the ratio of the General Parity Index (GPI) in Burundi in 1992 to that in 2001?
Offer a terse response. 1.03. What is the ratio of the General Parity Index (GPI) of Peru in 1992 to that in 2001?
Provide a succinct answer. 0.98. What is the ratio of the General Parity Index (GPI) of Sri Lanka in 1992 to that in 2001?
Make the answer very short. 0.98. What is the ratio of the General Parity Index (GPI) in Belgium in 1992 to that in 2002?
Give a very brief answer. 1.02. What is the ratio of the General Parity Index (GPI) in Burundi in 1992 to that in 2002?
Make the answer very short. 1.05. What is the ratio of the General Parity Index (GPI) of Sri Lanka in 1992 to that in 2002?
Provide a succinct answer. 0.98. What is the ratio of the General Parity Index (GPI) of Belgium in 1992 to that in 2003?
Offer a very short reply. 1.02. What is the ratio of the General Parity Index (GPI) of Burundi in 1992 to that in 2003?
Your answer should be compact. 1.03. What is the ratio of the General Parity Index (GPI) of Sri Lanka in 1992 to that in 2003?
Keep it short and to the point. 0.97. What is the ratio of the General Parity Index (GPI) of Belgium in 1993 to that in 1995?
Offer a very short reply. 1. What is the ratio of the General Parity Index (GPI) in Burundi in 1993 to that in 1995?
Your answer should be very brief. 1.02. What is the ratio of the General Parity Index (GPI) of Peru in 1993 to that in 1995?
Your answer should be compact. 1. What is the ratio of the General Parity Index (GPI) in Burundi in 1993 to that in 2001?
Your answer should be compact. 1.04. What is the ratio of the General Parity Index (GPI) in Peru in 1993 to that in 2001?
Make the answer very short. 0.98. What is the ratio of the General Parity Index (GPI) of Sri Lanka in 1993 to that in 2001?
Make the answer very short. 0.99. What is the ratio of the General Parity Index (GPI) in Belgium in 1993 to that in 2002?
Provide a short and direct response. 1. What is the ratio of the General Parity Index (GPI) of Burundi in 1993 to that in 2002?
Provide a short and direct response. 1.06. What is the ratio of the General Parity Index (GPI) of Peru in 1993 to that in 2002?
Your response must be concise. 0.98. What is the ratio of the General Parity Index (GPI) in Sri Lanka in 1993 to that in 2002?
Provide a succinct answer. 0.98. What is the ratio of the General Parity Index (GPI) in Belgium in 1993 to that in 2003?
Your answer should be very brief. 1. What is the ratio of the General Parity Index (GPI) in Burundi in 1993 to that in 2003?
Give a very brief answer. 1.03. What is the ratio of the General Parity Index (GPI) in Peru in 1993 to that in 2003?
Make the answer very short. 0.98. What is the ratio of the General Parity Index (GPI) of Sri Lanka in 1993 to that in 2003?
Your response must be concise. 0.97. What is the ratio of the General Parity Index (GPI) of Burundi in 1995 to that in 2001?
Ensure brevity in your answer.  1.01. What is the ratio of the General Parity Index (GPI) in Peru in 1995 to that in 2001?
Give a very brief answer. 0.98. What is the ratio of the General Parity Index (GPI) of Sri Lanka in 1995 to that in 2001?
Keep it short and to the point. 0.99. What is the ratio of the General Parity Index (GPI) in Belgium in 1995 to that in 2002?
Offer a terse response. 1. What is the ratio of the General Parity Index (GPI) of Burundi in 1995 to that in 2002?
Offer a very short reply. 1.03. What is the ratio of the General Parity Index (GPI) in Peru in 1995 to that in 2002?
Your answer should be compact. 0.98. What is the ratio of the General Parity Index (GPI) in Sri Lanka in 1995 to that in 2002?
Your answer should be very brief. 0.98. What is the ratio of the General Parity Index (GPI) of Burundi in 1995 to that in 2003?
Offer a very short reply. 1.01. What is the ratio of the General Parity Index (GPI) in Peru in 1995 to that in 2003?
Provide a short and direct response. 0.98. What is the ratio of the General Parity Index (GPI) in Sri Lanka in 1995 to that in 2003?
Make the answer very short. 0.97. What is the ratio of the General Parity Index (GPI) in Burundi in 2001 to that in 2002?
Give a very brief answer. 1.02. What is the ratio of the General Parity Index (GPI) in Belgium in 2001 to that in 2003?
Give a very brief answer. 1. What is the ratio of the General Parity Index (GPI) of Burundi in 2001 to that in 2003?
Keep it short and to the point. 0.99. What is the ratio of the General Parity Index (GPI) in Sri Lanka in 2001 to that in 2003?
Give a very brief answer. 0.99. What is the ratio of the General Parity Index (GPI) of Burundi in 2002 to that in 2003?
Offer a very short reply. 0.98. What is the ratio of the General Parity Index (GPI) of Peru in 2002 to that in 2003?
Provide a succinct answer. 1. What is the ratio of the General Parity Index (GPI) in Sri Lanka in 2002 to that in 2003?
Your answer should be compact. 0.99. What is the difference between the highest and the second highest General Parity Index (GPI) of Belgium?
Offer a terse response. 0. What is the difference between the highest and the second highest General Parity Index (GPI) of Burundi?
Offer a very short reply. 0.02. What is the difference between the highest and the second highest General Parity Index (GPI) of Peru?
Offer a very short reply. 0. What is the difference between the highest and the second highest General Parity Index (GPI) of Sri Lanka?
Your answer should be very brief. 0.01. What is the difference between the highest and the lowest General Parity Index (GPI) in Belgium?
Keep it short and to the point. 0.03. What is the difference between the highest and the lowest General Parity Index (GPI) of Burundi?
Your answer should be compact. 0.16. What is the difference between the highest and the lowest General Parity Index (GPI) of Peru?
Provide a short and direct response. 0.04. What is the difference between the highest and the lowest General Parity Index (GPI) of Sri Lanka?
Your answer should be very brief. 0.03. 